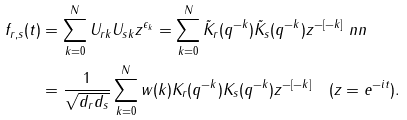<formula> <loc_0><loc_0><loc_500><loc_500>f _ { r , s } ( t ) & = \sum _ { k = 0 } ^ { N } U _ { r k } U _ { s k } z ^ { \epsilon _ { k } } = \sum _ { k = 0 } ^ { N } \tilde { K } _ { r } ( q ^ { - k } ) \tilde { K } _ { s } ( q ^ { - k } ) z ^ { - [ - k ] } \ n n \\ & = \frac { 1 } { \sqrt { d _ { r } d _ { s } } } \sum _ { k = 0 } ^ { N } w ( k ) K _ { r } ( q ^ { - k } ) K _ { s } ( q ^ { - k } ) z ^ { - [ - k ] } \quad ( z = e ^ { - i t } ) .</formula> 